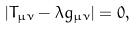<formula> <loc_0><loc_0><loc_500><loc_500>| T _ { \mu \nu } - \lambda g _ { \mu \nu } | = 0 ,</formula> 